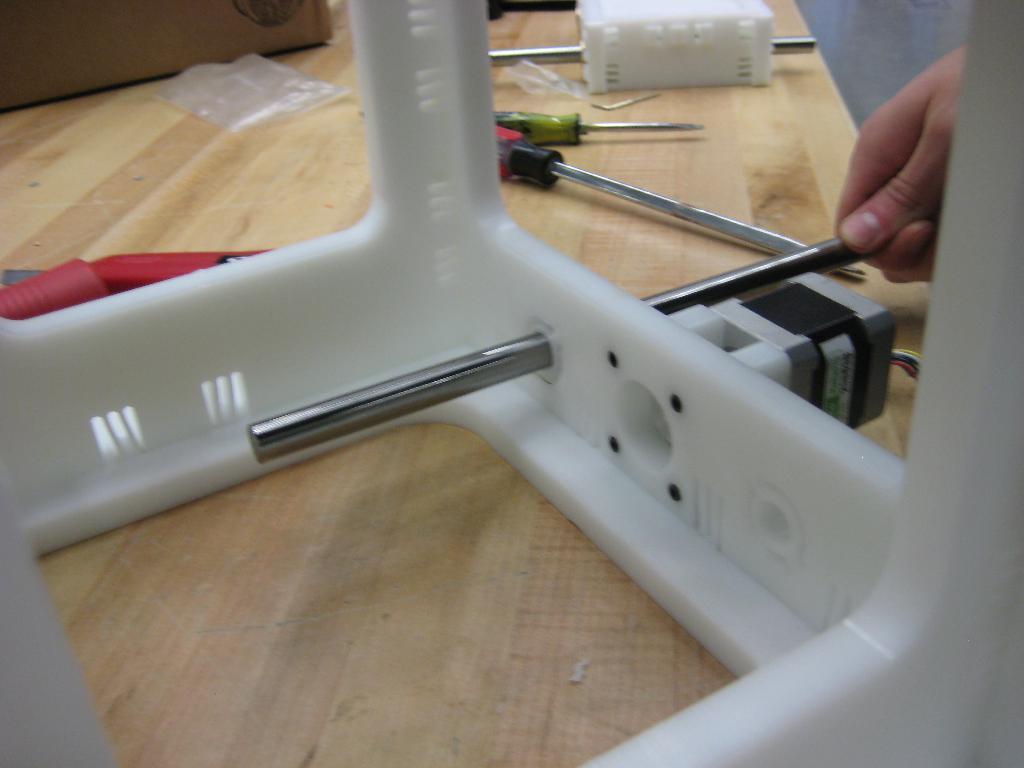Please provide a concise description of this image. In the center of the image we can see one table. On the table, we can see one white color object, One white color box, screwdrivers, one red color object, one brown color box and a few other objects. On the right side of the image, we can see one human hand holding some object. 